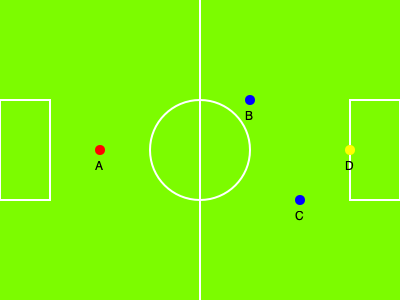In the simplified football field shown above, player A (red) is from the attacking team, players B and C (blue) are defenders, and D (yellow) is the goalkeeper. Which player(s) is/are in an offside position? To determine if a player is in an offside position, we need to consider the following rules:

1. A player is in an offside position if they are closer to the opponent's goal line than both the ball and the second-last opponent.
2. The goalkeeper is considered the last opponent.
3. A player cannot be offside in their own half of the field.

Let's analyze each player's position:

1. Player A (red):
   - Is in the opponent's half of the field
   - Is behind the ball (which is not shown but assumed to be with a teammate further back)
   - Is behind the second-last defender (player C)
   Therefore, player A is not in an offside position.

2. Players B and C (blue):
   These are defending players, so the offside rule does not apply to them.

3. Player D (yellow):
   This is the goalkeeper, so the offside rule does not apply.

In conclusion, no player is in an offside position in this scenario.
Answer: None 